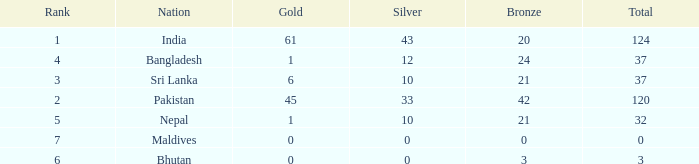How much Silver has a Rank of 7? 1.0. 